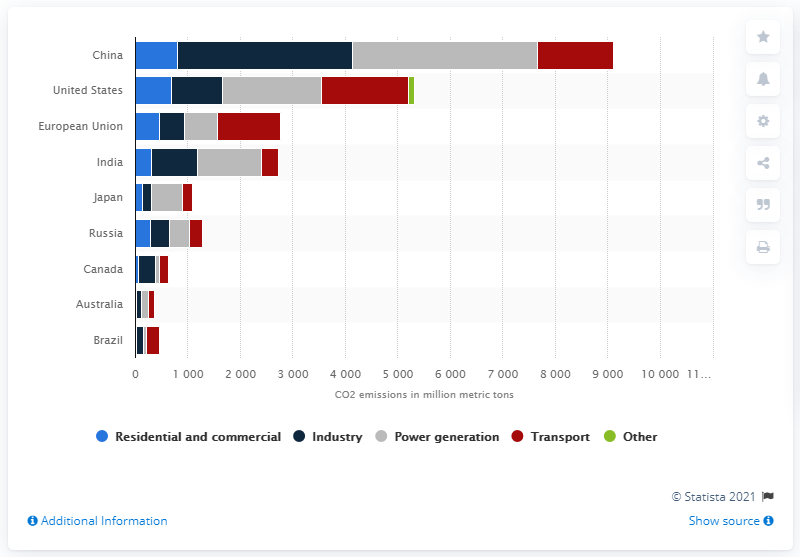List a handful of essential elements in this visual. In 2017, the Chinese industrial sector emitted approximately 33,300 metric tons of carbon dioxide. 